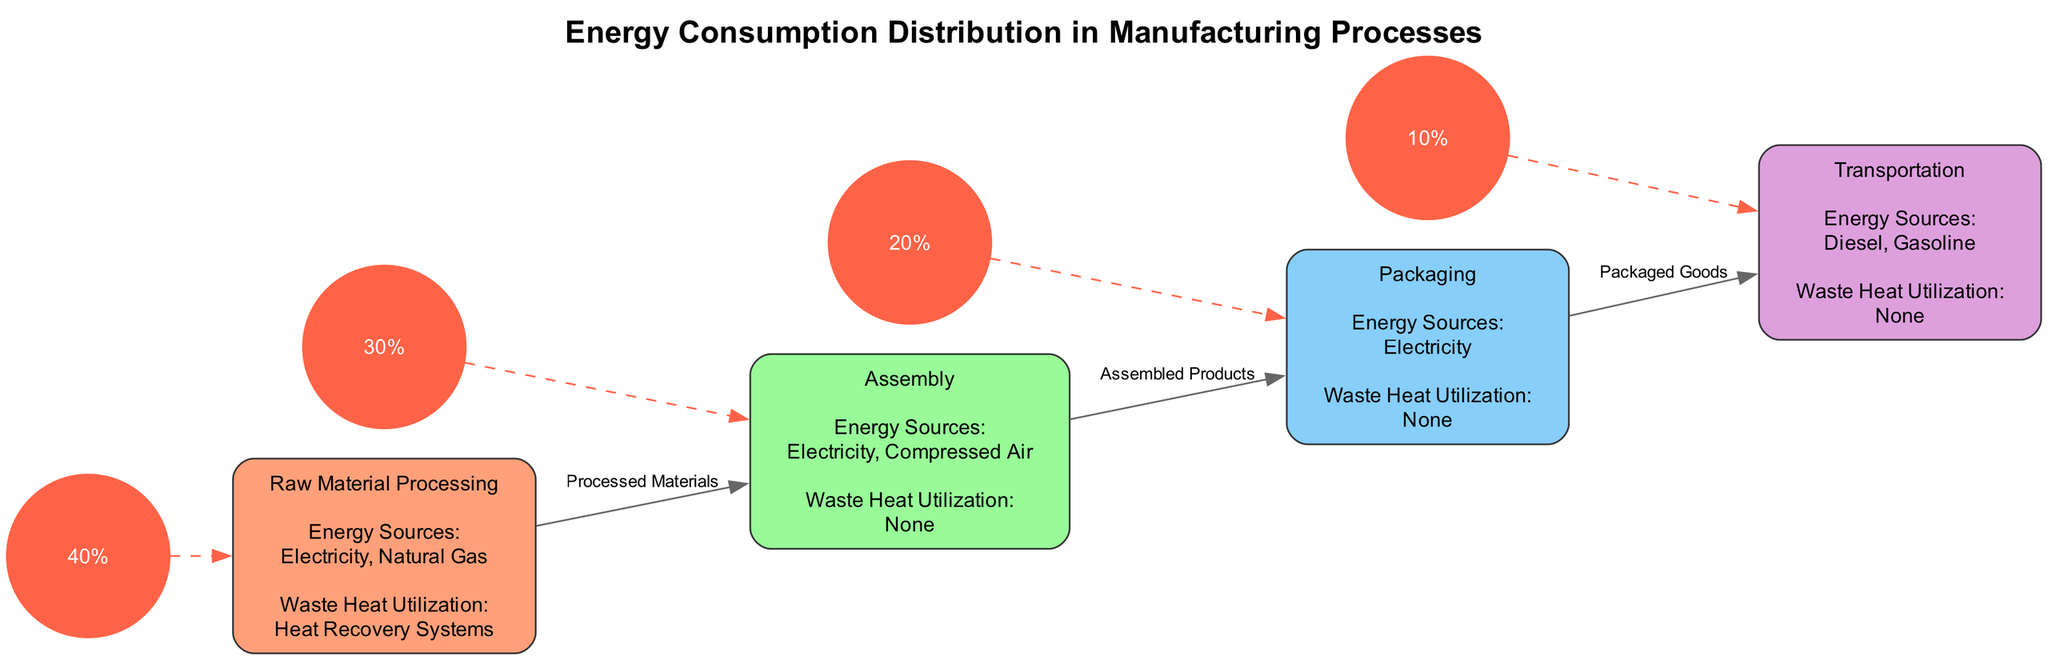What is the energy consumption percentage for Raw Material Processing? The diagram indicates that Raw Material Processing consumes 40% of the total energy. This percentage is explicitly stated in the summary section of the diagram.
Answer: 40% Which stage utilizes heat recovery systems? According to the annotations in the diagram, Raw Material Processing is the only stage that utilizes heat recovery systems for waste heat utilization.
Answer: Raw Material Processing What is the main energy source for Assembly? The diagram specifies that the main energy sources for the Assembly stage are Electricity and Compressed Air, as indicated in its annotations.
Answer: Electricity, Compressed Air How many manufacturing stages are depicted in the diagram? The diagram showcases four stages: Raw Material Processing, Assembly, Packaging, and Transportation, making a total of four distinct stages.
Answer: 4 Which manufacturing stage has the lowest energy consumption percentage? The energy consumption percentage for Transportation is 10%, which is the lowest among all the manufacturing stages depicted in the diagram. The summary section provides this information.
Answer: 10% What is the relationship between Packaging and Transportation? The diagram shows that Packaging sends Packaged Goods to the Transportation stage, indicating a direct connection between these two stages in the manufacturing process.
Answer: Packaged Goods What is the energy source for Packaging? The diagram states that the only energy source for the Packaging stage is Electricity, which is clearly mentioned in the annotations.
Answer: Electricity Which manufacturing stage does not utilize waste heat? Both the Assembly and Packaging stages do not utilize waste heat, as indicated in their respective annotations that note "None" for waste heat utilization.
Answer: Assembly, Packaging What connects Assembly to Packaging in the diagram? The diagram indicates that the connection from Assembly to Packaging is represented by the term "Assembled Products," which defines the flow between these two stages.
Answer: Assembled Products 